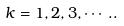Convert formula to latex. <formula><loc_0><loc_0><loc_500><loc_500>k = 1 , 2 , 3 , \cdots . .</formula> 